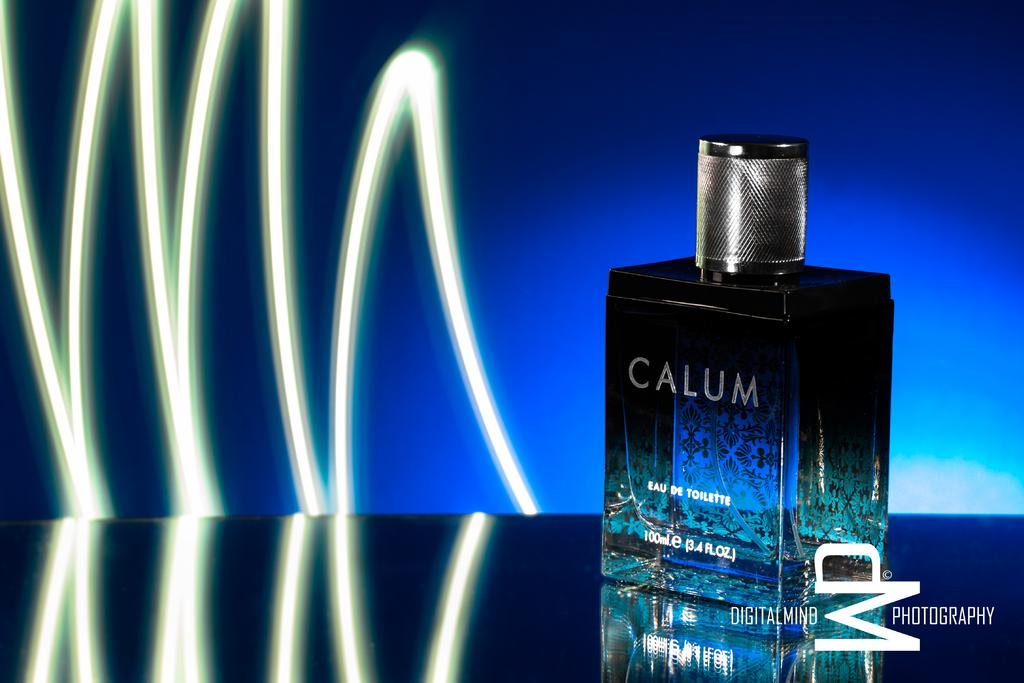<image>
Create a compact narrative representing the image presented. A square bottle that has the words Calum on it. 